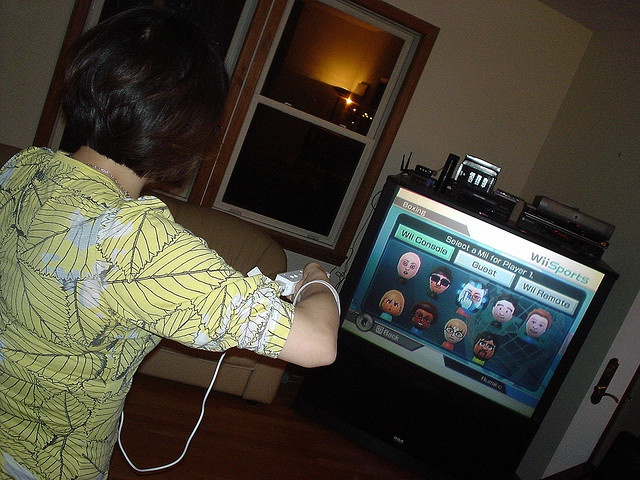Describe the objects in this image and their specific colors. I can see people in black, olive, khaki, and gray tones, tv in black, blue, white, and gray tones, couch in black and gray tones, and remote in black, lightgray, darkgray, gray, and khaki tones in this image. 